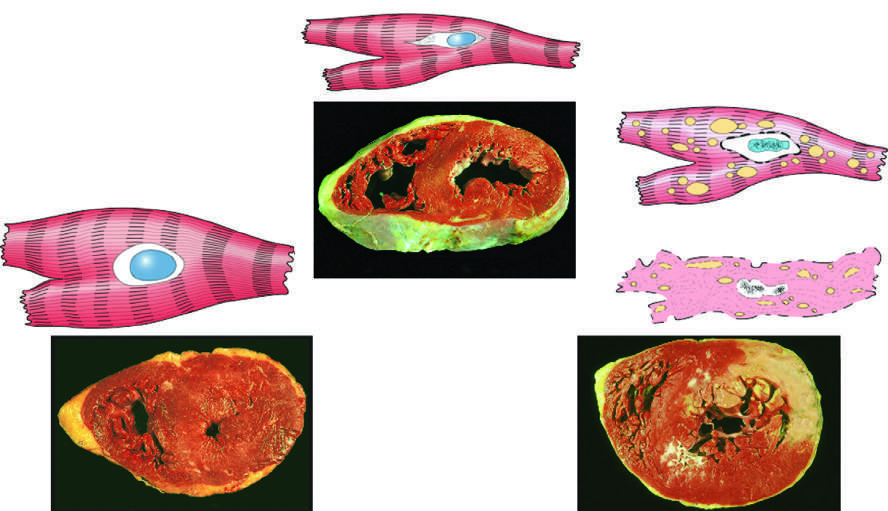what is the cause of reversible injury?
Answer the question using a single word or phrase. Ischemia 